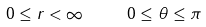Convert formula to latex. <formula><loc_0><loc_0><loc_500><loc_500>0 \leq r < \infty \quad \ 0 \leq \theta \leq \pi</formula> 